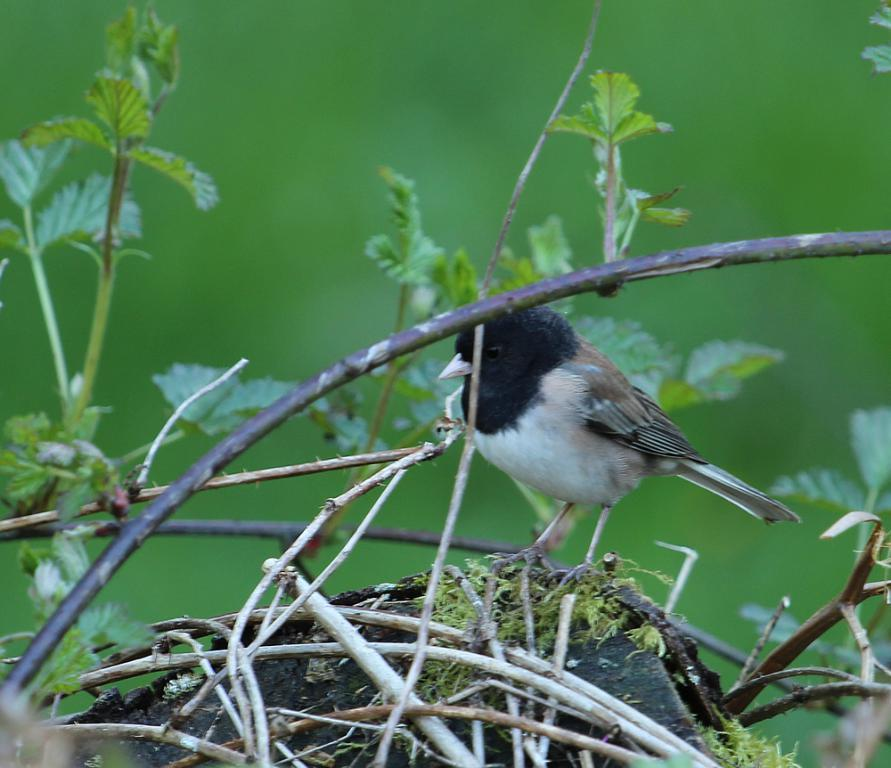What type of animal is in the image? There is a bird in the image. What is the bird doing in the image? The bird is standing on a surface. What can be seen in the image besides the bird? There are stems and green leaves in the image. What color is the background of the image? The background of the image is green. What type of throne is the bird sitting on in the image? There is no throne present in the image; the bird is standing on a surface. 